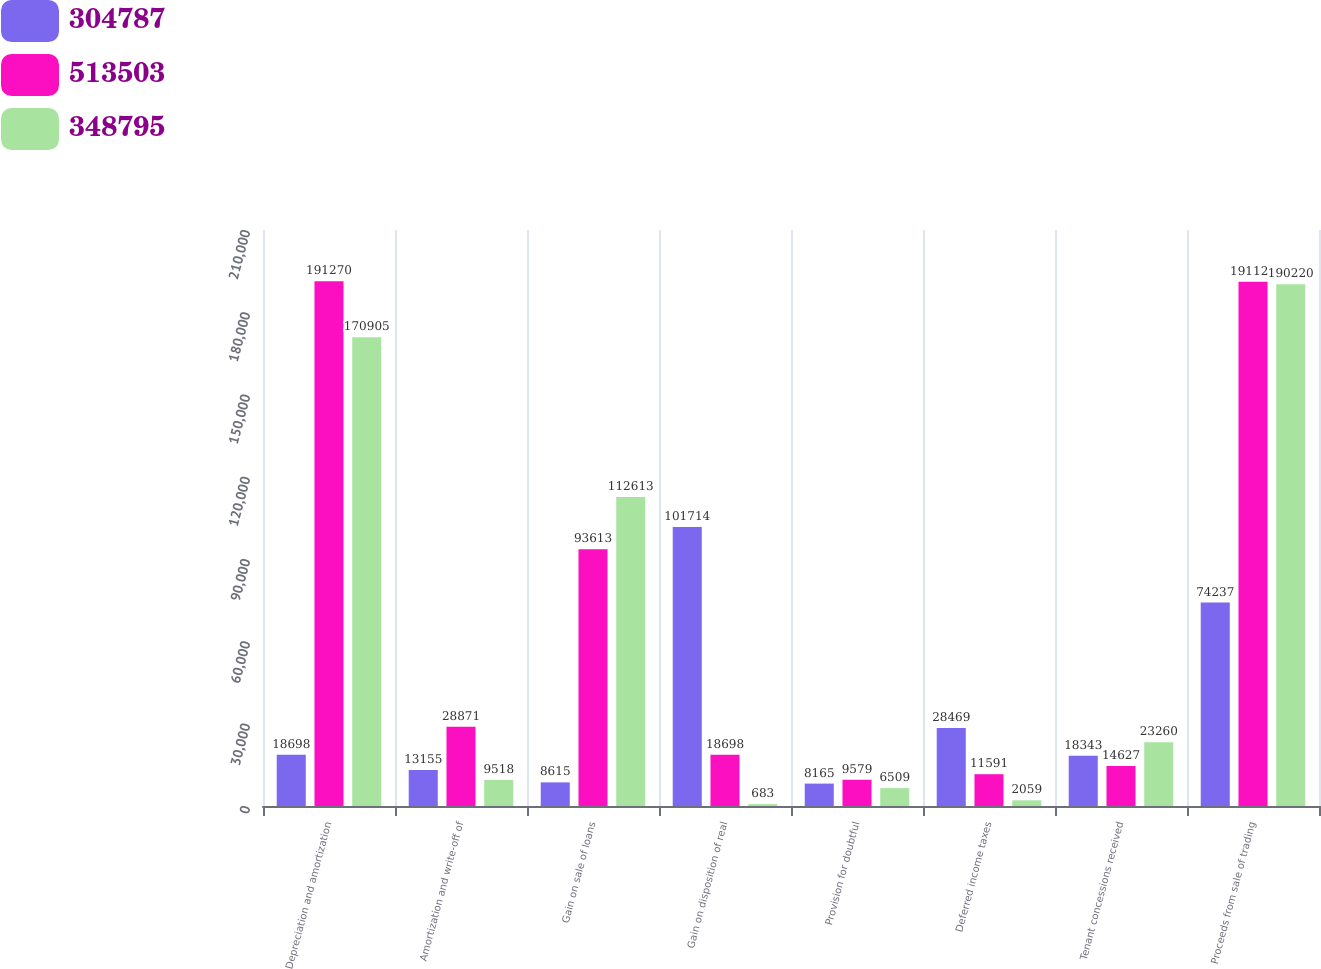<chart> <loc_0><loc_0><loc_500><loc_500><stacked_bar_chart><ecel><fcel>Depreciation and amortization<fcel>Amortization and write-off of<fcel>Gain on sale of loans<fcel>Gain on disposition of real<fcel>Provision for doubtful<fcel>Deferred income taxes<fcel>Tenant concessions received<fcel>Proceeds from sale of trading<nl><fcel>304787<fcel>18698<fcel>13155<fcel>8615<fcel>101714<fcel>8165<fcel>28469<fcel>18343<fcel>74237<nl><fcel>513503<fcel>191270<fcel>28871<fcel>93613<fcel>18698<fcel>9579<fcel>11591<fcel>14627<fcel>191121<nl><fcel>348795<fcel>170905<fcel>9518<fcel>112613<fcel>683<fcel>6509<fcel>2059<fcel>23260<fcel>190220<nl></chart> 